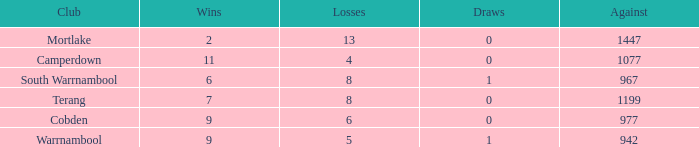How many wins did Cobden have when draws were more than 0? 0.0. Write the full table. {'header': ['Club', 'Wins', 'Losses', 'Draws', 'Against'], 'rows': [['Mortlake', '2', '13', '0', '1447'], ['Camperdown', '11', '4', '0', '1077'], ['South Warrnambool', '6', '8', '1', '967'], ['Terang', '7', '8', '0', '1199'], ['Cobden', '9', '6', '0', '977'], ['Warrnambool', '9', '5', '1', '942']]} 